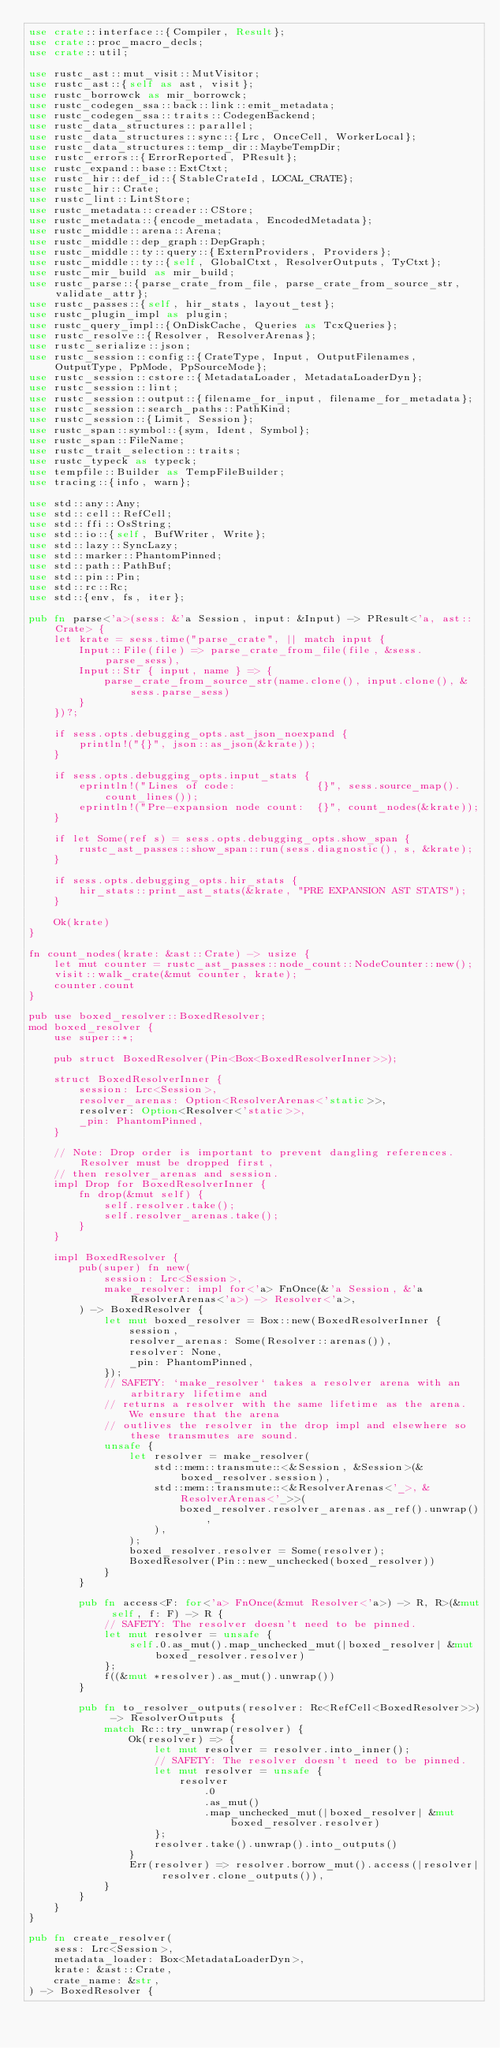Convert code to text. <code><loc_0><loc_0><loc_500><loc_500><_Rust_>use crate::interface::{Compiler, Result};
use crate::proc_macro_decls;
use crate::util;

use rustc_ast::mut_visit::MutVisitor;
use rustc_ast::{self as ast, visit};
use rustc_borrowck as mir_borrowck;
use rustc_codegen_ssa::back::link::emit_metadata;
use rustc_codegen_ssa::traits::CodegenBackend;
use rustc_data_structures::parallel;
use rustc_data_structures::sync::{Lrc, OnceCell, WorkerLocal};
use rustc_data_structures::temp_dir::MaybeTempDir;
use rustc_errors::{ErrorReported, PResult};
use rustc_expand::base::ExtCtxt;
use rustc_hir::def_id::{StableCrateId, LOCAL_CRATE};
use rustc_hir::Crate;
use rustc_lint::LintStore;
use rustc_metadata::creader::CStore;
use rustc_metadata::{encode_metadata, EncodedMetadata};
use rustc_middle::arena::Arena;
use rustc_middle::dep_graph::DepGraph;
use rustc_middle::ty::query::{ExternProviders, Providers};
use rustc_middle::ty::{self, GlobalCtxt, ResolverOutputs, TyCtxt};
use rustc_mir_build as mir_build;
use rustc_parse::{parse_crate_from_file, parse_crate_from_source_str, validate_attr};
use rustc_passes::{self, hir_stats, layout_test};
use rustc_plugin_impl as plugin;
use rustc_query_impl::{OnDiskCache, Queries as TcxQueries};
use rustc_resolve::{Resolver, ResolverArenas};
use rustc_serialize::json;
use rustc_session::config::{CrateType, Input, OutputFilenames, OutputType, PpMode, PpSourceMode};
use rustc_session::cstore::{MetadataLoader, MetadataLoaderDyn};
use rustc_session::lint;
use rustc_session::output::{filename_for_input, filename_for_metadata};
use rustc_session::search_paths::PathKind;
use rustc_session::{Limit, Session};
use rustc_span::symbol::{sym, Ident, Symbol};
use rustc_span::FileName;
use rustc_trait_selection::traits;
use rustc_typeck as typeck;
use tempfile::Builder as TempFileBuilder;
use tracing::{info, warn};

use std::any::Any;
use std::cell::RefCell;
use std::ffi::OsString;
use std::io::{self, BufWriter, Write};
use std::lazy::SyncLazy;
use std::marker::PhantomPinned;
use std::path::PathBuf;
use std::pin::Pin;
use std::rc::Rc;
use std::{env, fs, iter};

pub fn parse<'a>(sess: &'a Session, input: &Input) -> PResult<'a, ast::Crate> {
    let krate = sess.time("parse_crate", || match input {
        Input::File(file) => parse_crate_from_file(file, &sess.parse_sess),
        Input::Str { input, name } => {
            parse_crate_from_source_str(name.clone(), input.clone(), &sess.parse_sess)
        }
    })?;

    if sess.opts.debugging_opts.ast_json_noexpand {
        println!("{}", json::as_json(&krate));
    }

    if sess.opts.debugging_opts.input_stats {
        eprintln!("Lines of code:             {}", sess.source_map().count_lines());
        eprintln!("Pre-expansion node count:  {}", count_nodes(&krate));
    }

    if let Some(ref s) = sess.opts.debugging_opts.show_span {
        rustc_ast_passes::show_span::run(sess.diagnostic(), s, &krate);
    }

    if sess.opts.debugging_opts.hir_stats {
        hir_stats::print_ast_stats(&krate, "PRE EXPANSION AST STATS");
    }

    Ok(krate)
}

fn count_nodes(krate: &ast::Crate) -> usize {
    let mut counter = rustc_ast_passes::node_count::NodeCounter::new();
    visit::walk_crate(&mut counter, krate);
    counter.count
}

pub use boxed_resolver::BoxedResolver;
mod boxed_resolver {
    use super::*;

    pub struct BoxedResolver(Pin<Box<BoxedResolverInner>>);

    struct BoxedResolverInner {
        session: Lrc<Session>,
        resolver_arenas: Option<ResolverArenas<'static>>,
        resolver: Option<Resolver<'static>>,
        _pin: PhantomPinned,
    }

    // Note: Drop order is important to prevent dangling references. Resolver must be dropped first,
    // then resolver_arenas and session.
    impl Drop for BoxedResolverInner {
        fn drop(&mut self) {
            self.resolver.take();
            self.resolver_arenas.take();
        }
    }

    impl BoxedResolver {
        pub(super) fn new(
            session: Lrc<Session>,
            make_resolver: impl for<'a> FnOnce(&'a Session, &'a ResolverArenas<'a>) -> Resolver<'a>,
        ) -> BoxedResolver {
            let mut boxed_resolver = Box::new(BoxedResolverInner {
                session,
                resolver_arenas: Some(Resolver::arenas()),
                resolver: None,
                _pin: PhantomPinned,
            });
            // SAFETY: `make_resolver` takes a resolver arena with an arbitrary lifetime and
            // returns a resolver with the same lifetime as the arena. We ensure that the arena
            // outlives the resolver in the drop impl and elsewhere so these transmutes are sound.
            unsafe {
                let resolver = make_resolver(
                    std::mem::transmute::<&Session, &Session>(&boxed_resolver.session),
                    std::mem::transmute::<&ResolverArenas<'_>, &ResolverArenas<'_>>(
                        boxed_resolver.resolver_arenas.as_ref().unwrap(),
                    ),
                );
                boxed_resolver.resolver = Some(resolver);
                BoxedResolver(Pin::new_unchecked(boxed_resolver))
            }
        }

        pub fn access<F: for<'a> FnOnce(&mut Resolver<'a>) -> R, R>(&mut self, f: F) -> R {
            // SAFETY: The resolver doesn't need to be pinned.
            let mut resolver = unsafe {
                self.0.as_mut().map_unchecked_mut(|boxed_resolver| &mut boxed_resolver.resolver)
            };
            f((&mut *resolver).as_mut().unwrap())
        }

        pub fn to_resolver_outputs(resolver: Rc<RefCell<BoxedResolver>>) -> ResolverOutputs {
            match Rc::try_unwrap(resolver) {
                Ok(resolver) => {
                    let mut resolver = resolver.into_inner();
                    // SAFETY: The resolver doesn't need to be pinned.
                    let mut resolver = unsafe {
                        resolver
                            .0
                            .as_mut()
                            .map_unchecked_mut(|boxed_resolver| &mut boxed_resolver.resolver)
                    };
                    resolver.take().unwrap().into_outputs()
                }
                Err(resolver) => resolver.borrow_mut().access(|resolver| resolver.clone_outputs()),
            }
        }
    }
}

pub fn create_resolver(
    sess: Lrc<Session>,
    metadata_loader: Box<MetadataLoaderDyn>,
    krate: &ast::Crate,
    crate_name: &str,
) -> BoxedResolver {</code> 